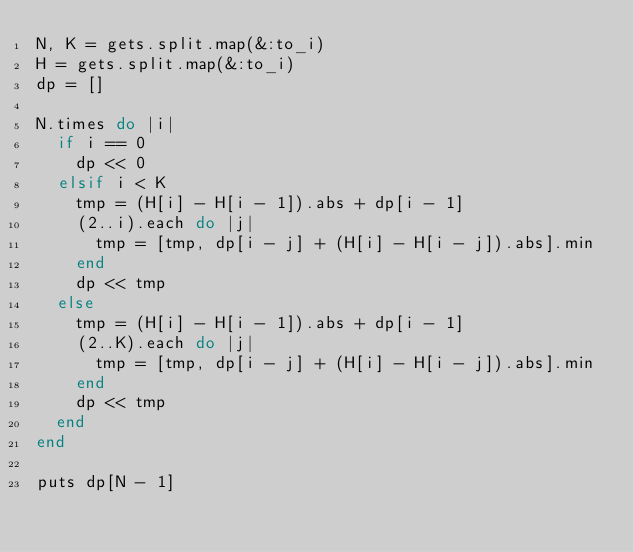<code> <loc_0><loc_0><loc_500><loc_500><_Ruby_>N, K = gets.split.map(&:to_i)
H = gets.split.map(&:to_i)
dp = []

N.times do |i|
  if i == 0
    dp << 0
  elsif i < K
    tmp = (H[i] - H[i - 1]).abs + dp[i - 1]
    (2..i).each do |j|
      tmp = [tmp, dp[i - j] + (H[i] - H[i - j]).abs].min
    end
    dp << tmp
  else
    tmp = (H[i] - H[i - 1]).abs + dp[i - 1]
    (2..K).each do |j|
      tmp = [tmp, dp[i - j] + (H[i] - H[i - j]).abs].min
    end
    dp << tmp
  end
end

puts dp[N - 1]</code> 